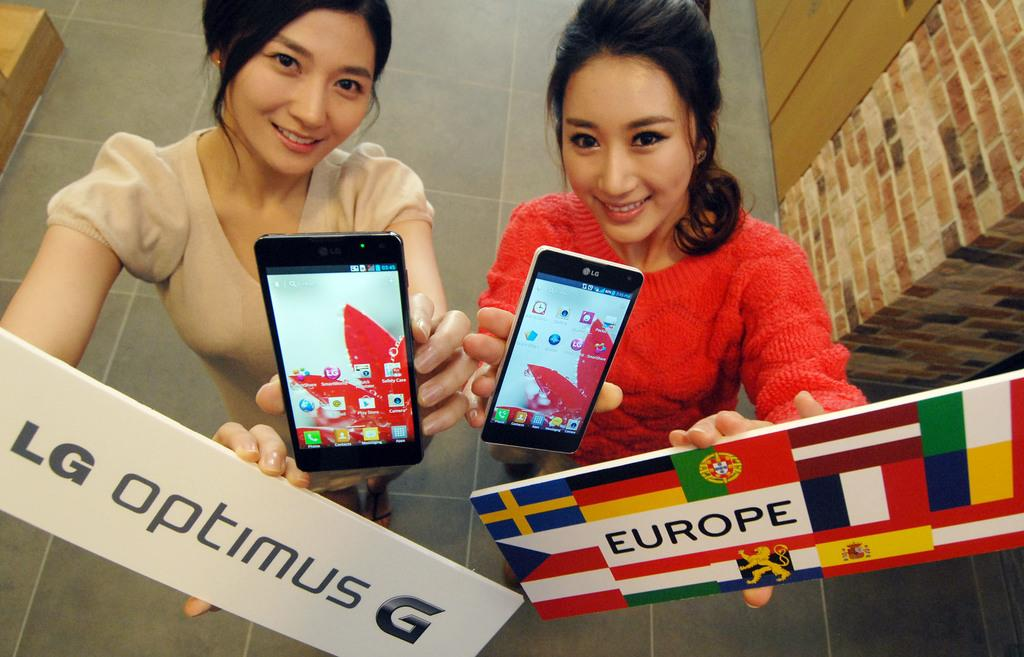Provide a one-sentence caption for the provided image. Two women holding LG optimus G phone and europe sign. 